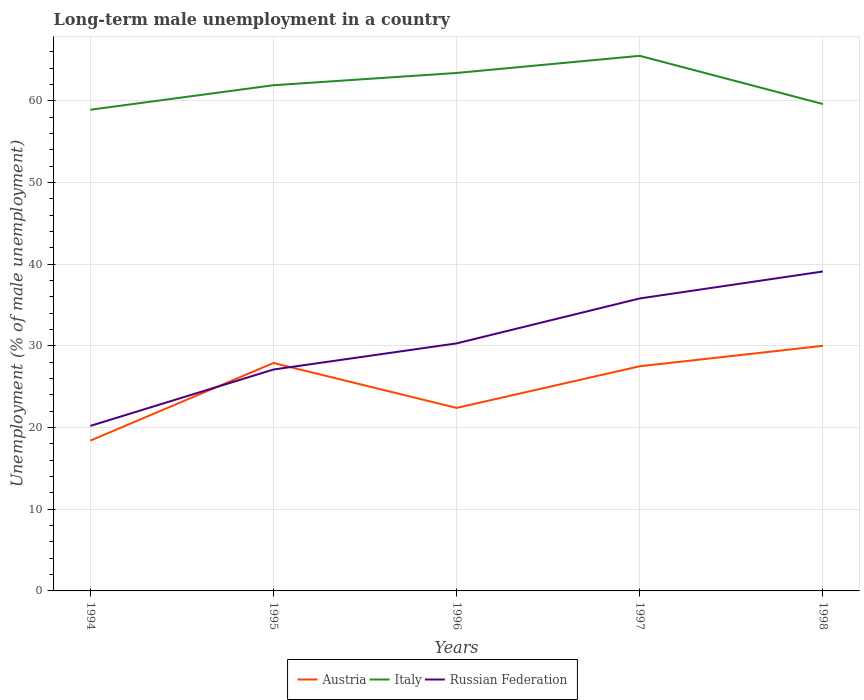How many different coloured lines are there?
Keep it short and to the point. 3. Does the line corresponding to Italy intersect with the line corresponding to Russian Federation?
Give a very brief answer. No. Is the number of lines equal to the number of legend labels?
Offer a very short reply. Yes. Across all years, what is the maximum percentage of long-term unemployed male population in Russian Federation?
Make the answer very short. 20.2. In which year was the percentage of long-term unemployed male population in Austria maximum?
Ensure brevity in your answer.  1994. What is the total percentage of long-term unemployed male population in Italy in the graph?
Give a very brief answer. -3.6. What is the difference between the highest and the second highest percentage of long-term unemployed male population in Russian Federation?
Ensure brevity in your answer.  18.9. What is the difference between the highest and the lowest percentage of long-term unemployed male population in Italy?
Give a very brief answer. 3. Is the percentage of long-term unemployed male population in Russian Federation strictly greater than the percentage of long-term unemployed male population in Italy over the years?
Make the answer very short. Yes. How many lines are there?
Make the answer very short. 3. Are the values on the major ticks of Y-axis written in scientific E-notation?
Give a very brief answer. No. Does the graph contain grids?
Provide a short and direct response. Yes. Where does the legend appear in the graph?
Your answer should be very brief. Bottom center. How many legend labels are there?
Provide a succinct answer. 3. How are the legend labels stacked?
Your answer should be compact. Horizontal. What is the title of the graph?
Your response must be concise. Long-term male unemployment in a country. What is the label or title of the Y-axis?
Offer a terse response. Unemployment (% of male unemployment). What is the Unemployment (% of male unemployment) of Austria in 1994?
Offer a terse response. 18.4. What is the Unemployment (% of male unemployment) in Italy in 1994?
Give a very brief answer. 58.9. What is the Unemployment (% of male unemployment) in Russian Federation in 1994?
Ensure brevity in your answer.  20.2. What is the Unemployment (% of male unemployment) of Austria in 1995?
Provide a short and direct response. 27.9. What is the Unemployment (% of male unemployment) of Italy in 1995?
Give a very brief answer. 61.9. What is the Unemployment (% of male unemployment) of Russian Federation in 1995?
Give a very brief answer. 27.1. What is the Unemployment (% of male unemployment) in Austria in 1996?
Your answer should be very brief. 22.4. What is the Unemployment (% of male unemployment) of Italy in 1996?
Offer a terse response. 63.4. What is the Unemployment (% of male unemployment) of Russian Federation in 1996?
Provide a short and direct response. 30.3. What is the Unemployment (% of male unemployment) of Italy in 1997?
Provide a short and direct response. 65.5. What is the Unemployment (% of male unemployment) in Russian Federation in 1997?
Provide a succinct answer. 35.8. What is the Unemployment (% of male unemployment) of Italy in 1998?
Your response must be concise. 59.6. What is the Unemployment (% of male unemployment) in Russian Federation in 1998?
Your response must be concise. 39.1. Across all years, what is the maximum Unemployment (% of male unemployment) of Austria?
Provide a succinct answer. 30. Across all years, what is the maximum Unemployment (% of male unemployment) of Italy?
Make the answer very short. 65.5. Across all years, what is the maximum Unemployment (% of male unemployment) in Russian Federation?
Offer a terse response. 39.1. Across all years, what is the minimum Unemployment (% of male unemployment) in Austria?
Ensure brevity in your answer.  18.4. Across all years, what is the minimum Unemployment (% of male unemployment) of Italy?
Your answer should be very brief. 58.9. Across all years, what is the minimum Unemployment (% of male unemployment) of Russian Federation?
Ensure brevity in your answer.  20.2. What is the total Unemployment (% of male unemployment) of Austria in the graph?
Your response must be concise. 126.2. What is the total Unemployment (% of male unemployment) of Italy in the graph?
Make the answer very short. 309.3. What is the total Unemployment (% of male unemployment) in Russian Federation in the graph?
Give a very brief answer. 152.5. What is the difference between the Unemployment (% of male unemployment) of Austria in 1994 and that in 1995?
Your response must be concise. -9.5. What is the difference between the Unemployment (% of male unemployment) in Russian Federation in 1994 and that in 1995?
Your response must be concise. -6.9. What is the difference between the Unemployment (% of male unemployment) of Italy in 1994 and that in 1996?
Offer a very short reply. -4.5. What is the difference between the Unemployment (% of male unemployment) of Russian Federation in 1994 and that in 1996?
Your answer should be very brief. -10.1. What is the difference between the Unemployment (% of male unemployment) of Russian Federation in 1994 and that in 1997?
Provide a succinct answer. -15.6. What is the difference between the Unemployment (% of male unemployment) of Austria in 1994 and that in 1998?
Your answer should be very brief. -11.6. What is the difference between the Unemployment (% of male unemployment) in Russian Federation in 1994 and that in 1998?
Give a very brief answer. -18.9. What is the difference between the Unemployment (% of male unemployment) of Austria in 1995 and that in 1996?
Offer a terse response. 5.5. What is the difference between the Unemployment (% of male unemployment) in Russian Federation in 1995 and that in 1996?
Make the answer very short. -3.2. What is the difference between the Unemployment (% of male unemployment) in Austria in 1995 and that in 1997?
Your response must be concise. 0.4. What is the difference between the Unemployment (% of male unemployment) in Russian Federation in 1995 and that in 1998?
Give a very brief answer. -12. What is the difference between the Unemployment (% of male unemployment) in Italy in 1996 and that in 1997?
Your answer should be very brief. -2.1. What is the difference between the Unemployment (% of male unemployment) of Austria in 1996 and that in 1998?
Offer a very short reply. -7.6. What is the difference between the Unemployment (% of male unemployment) of Italy in 1996 and that in 1998?
Give a very brief answer. 3.8. What is the difference between the Unemployment (% of male unemployment) in Austria in 1997 and that in 1998?
Provide a succinct answer. -2.5. What is the difference between the Unemployment (% of male unemployment) of Italy in 1997 and that in 1998?
Keep it short and to the point. 5.9. What is the difference between the Unemployment (% of male unemployment) in Russian Federation in 1997 and that in 1998?
Your response must be concise. -3.3. What is the difference between the Unemployment (% of male unemployment) of Austria in 1994 and the Unemployment (% of male unemployment) of Italy in 1995?
Give a very brief answer. -43.5. What is the difference between the Unemployment (% of male unemployment) of Italy in 1994 and the Unemployment (% of male unemployment) of Russian Federation in 1995?
Provide a short and direct response. 31.8. What is the difference between the Unemployment (% of male unemployment) in Austria in 1994 and the Unemployment (% of male unemployment) in Italy in 1996?
Make the answer very short. -45. What is the difference between the Unemployment (% of male unemployment) of Italy in 1994 and the Unemployment (% of male unemployment) of Russian Federation in 1996?
Offer a terse response. 28.6. What is the difference between the Unemployment (% of male unemployment) of Austria in 1994 and the Unemployment (% of male unemployment) of Italy in 1997?
Offer a very short reply. -47.1. What is the difference between the Unemployment (% of male unemployment) of Austria in 1994 and the Unemployment (% of male unemployment) of Russian Federation in 1997?
Your response must be concise. -17.4. What is the difference between the Unemployment (% of male unemployment) of Italy in 1994 and the Unemployment (% of male unemployment) of Russian Federation in 1997?
Give a very brief answer. 23.1. What is the difference between the Unemployment (% of male unemployment) of Austria in 1994 and the Unemployment (% of male unemployment) of Italy in 1998?
Make the answer very short. -41.2. What is the difference between the Unemployment (% of male unemployment) in Austria in 1994 and the Unemployment (% of male unemployment) in Russian Federation in 1998?
Keep it short and to the point. -20.7. What is the difference between the Unemployment (% of male unemployment) in Italy in 1994 and the Unemployment (% of male unemployment) in Russian Federation in 1998?
Ensure brevity in your answer.  19.8. What is the difference between the Unemployment (% of male unemployment) of Austria in 1995 and the Unemployment (% of male unemployment) of Italy in 1996?
Give a very brief answer. -35.5. What is the difference between the Unemployment (% of male unemployment) of Italy in 1995 and the Unemployment (% of male unemployment) of Russian Federation in 1996?
Offer a very short reply. 31.6. What is the difference between the Unemployment (% of male unemployment) of Austria in 1995 and the Unemployment (% of male unemployment) of Italy in 1997?
Keep it short and to the point. -37.6. What is the difference between the Unemployment (% of male unemployment) in Austria in 1995 and the Unemployment (% of male unemployment) in Russian Federation in 1997?
Offer a terse response. -7.9. What is the difference between the Unemployment (% of male unemployment) in Italy in 1995 and the Unemployment (% of male unemployment) in Russian Federation in 1997?
Make the answer very short. 26.1. What is the difference between the Unemployment (% of male unemployment) in Austria in 1995 and the Unemployment (% of male unemployment) in Italy in 1998?
Offer a terse response. -31.7. What is the difference between the Unemployment (% of male unemployment) in Italy in 1995 and the Unemployment (% of male unemployment) in Russian Federation in 1998?
Provide a short and direct response. 22.8. What is the difference between the Unemployment (% of male unemployment) in Austria in 1996 and the Unemployment (% of male unemployment) in Italy in 1997?
Offer a terse response. -43.1. What is the difference between the Unemployment (% of male unemployment) in Austria in 1996 and the Unemployment (% of male unemployment) in Russian Federation in 1997?
Your response must be concise. -13.4. What is the difference between the Unemployment (% of male unemployment) in Italy in 1996 and the Unemployment (% of male unemployment) in Russian Federation in 1997?
Make the answer very short. 27.6. What is the difference between the Unemployment (% of male unemployment) of Austria in 1996 and the Unemployment (% of male unemployment) of Italy in 1998?
Offer a very short reply. -37.2. What is the difference between the Unemployment (% of male unemployment) in Austria in 1996 and the Unemployment (% of male unemployment) in Russian Federation in 1998?
Your answer should be compact. -16.7. What is the difference between the Unemployment (% of male unemployment) in Italy in 1996 and the Unemployment (% of male unemployment) in Russian Federation in 1998?
Make the answer very short. 24.3. What is the difference between the Unemployment (% of male unemployment) of Austria in 1997 and the Unemployment (% of male unemployment) of Italy in 1998?
Provide a succinct answer. -32.1. What is the difference between the Unemployment (% of male unemployment) of Austria in 1997 and the Unemployment (% of male unemployment) of Russian Federation in 1998?
Offer a very short reply. -11.6. What is the difference between the Unemployment (% of male unemployment) of Italy in 1997 and the Unemployment (% of male unemployment) of Russian Federation in 1998?
Make the answer very short. 26.4. What is the average Unemployment (% of male unemployment) in Austria per year?
Your answer should be compact. 25.24. What is the average Unemployment (% of male unemployment) of Italy per year?
Offer a terse response. 61.86. What is the average Unemployment (% of male unemployment) in Russian Federation per year?
Ensure brevity in your answer.  30.5. In the year 1994, what is the difference between the Unemployment (% of male unemployment) in Austria and Unemployment (% of male unemployment) in Italy?
Offer a terse response. -40.5. In the year 1994, what is the difference between the Unemployment (% of male unemployment) of Italy and Unemployment (% of male unemployment) of Russian Federation?
Provide a short and direct response. 38.7. In the year 1995, what is the difference between the Unemployment (% of male unemployment) of Austria and Unemployment (% of male unemployment) of Italy?
Provide a short and direct response. -34. In the year 1995, what is the difference between the Unemployment (% of male unemployment) in Italy and Unemployment (% of male unemployment) in Russian Federation?
Provide a short and direct response. 34.8. In the year 1996, what is the difference between the Unemployment (% of male unemployment) in Austria and Unemployment (% of male unemployment) in Italy?
Your answer should be very brief. -41. In the year 1996, what is the difference between the Unemployment (% of male unemployment) in Italy and Unemployment (% of male unemployment) in Russian Federation?
Ensure brevity in your answer.  33.1. In the year 1997, what is the difference between the Unemployment (% of male unemployment) of Austria and Unemployment (% of male unemployment) of Italy?
Your answer should be compact. -38. In the year 1997, what is the difference between the Unemployment (% of male unemployment) in Austria and Unemployment (% of male unemployment) in Russian Federation?
Keep it short and to the point. -8.3. In the year 1997, what is the difference between the Unemployment (% of male unemployment) of Italy and Unemployment (% of male unemployment) of Russian Federation?
Provide a short and direct response. 29.7. In the year 1998, what is the difference between the Unemployment (% of male unemployment) of Austria and Unemployment (% of male unemployment) of Italy?
Offer a very short reply. -29.6. In the year 1998, what is the difference between the Unemployment (% of male unemployment) of Austria and Unemployment (% of male unemployment) of Russian Federation?
Provide a succinct answer. -9.1. In the year 1998, what is the difference between the Unemployment (% of male unemployment) in Italy and Unemployment (% of male unemployment) in Russian Federation?
Your answer should be very brief. 20.5. What is the ratio of the Unemployment (% of male unemployment) of Austria in 1994 to that in 1995?
Provide a succinct answer. 0.66. What is the ratio of the Unemployment (% of male unemployment) in Italy in 1994 to that in 1995?
Make the answer very short. 0.95. What is the ratio of the Unemployment (% of male unemployment) of Russian Federation in 1994 to that in 1995?
Give a very brief answer. 0.75. What is the ratio of the Unemployment (% of male unemployment) in Austria in 1994 to that in 1996?
Offer a very short reply. 0.82. What is the ratio of the Unemployment (% of male unemployment) of Italy in 1994 to that in 1996?
Give a very brief answer. 0.93. What is the ratio of the Unemployment (% of male unemployment) in Russian Federation in 1994 to that in 1996?
Offer a very short reply. 0.67. What is the ratio of the Unemployment (% of male unemployment) of Austria in 1994 to that in 1997?
Keep it short and to the point. 0.67. What is the ratio of the Unemployment (% of male unemployment) of Italy in 1994 to that in 1997?
Offer a very short reply. 0.9. What is the ratio of the Unemployment (% of male unemployment) of Russian Federation in 1994 to that in 1997?
Ensure brevity in your answer.  0.56. What is the ratio of the Unemployment (% of male unemployment) in Austria in 1994 to that in 1998?
Ensure brevity in your answer.  0.61. What is the ratio of the Unemployment (% of male unemployment) in Italy in 1994 to that in 1998?
Offer a terse response. 0.99. What is the ratio of the Unemployment (% of male unemployment) of Russian Federation in 1994 to that in 1998?
Provide a short and direct response. 0.52. What is the ratio of the Unemployment (% of male unemployment) of Austria in 1995 to that in 1996?
Your answer should be very brief. 1.25. What is the ratio of the Unemployment (% of male unemployment) in Italy in 1995 to that in 1996?
Offer a very short reply. 0.98. What is the ratio of the Unemployment (% of male unemployment) of Russian Federation in 1995 to that in 1996?
Offer a very short reply. 0.89. What is the ratio of the Unemployment (% of male unemployment) in Austria in 1995 to that in 1997?
Keep it short and to the point. 1.01. What is the ratio of the Unemployment (% of male unemployment) in Italy in 1995 to that in 1997?
Offer a very short reply. 0.94. What is the ratio of the Unemployment (% of male unemployment) in Russian Federation in 1995 to that in 1997?
Give a very brief answer. 0.76. What is the ratio of the Unemployment (% of male unemployment) in Austria in 1995 to that in 1998?
Make the answer very short. 0.93. What is the ratio of the Unemployment (% of male unemployment) in Italy in 1995 to that in 1998?
Make the answer very short. 1.04. What is the ratio of the Unemployment (% of male unemployment) in Russian Federation in 1995 to that in 1998?
Your answer should be compact. 0.69. What is the ratio of the Unemployment (% of male unemployment) of Austria in 1996 to that in 1997?
Give a very brief answer. 0.81. What is the ratio of the Unemployment (% of male unemployment) of Italy in 1996 to that in 1997?
Offer a terse response. 0.97. What is the ratio of the Unemployment (% of male unemployment) of Russian Federation in 1996 to that in 1997?
Offer a terse response. 0.85. What is the ratio of the Unemployment (% of male unemployment) in Austria in 1996 to that in 1998?
Offer a very short reply. 0.75. What is the ratio of the Unemployment (% of male unemployment) of Italy in 1996 to that in 1998?
Provide a succinct answer. 1.06. What is the ratio of the Unemployment (% of male unemployment) of Russian Federation in 1996 to that in 1998?
Provide a short and direct response. 0.77. What is the ratio of the Unemployment (% of male unemployment) in Austria in 1997 to that in 1998?
Your answer should be very brief. 0.92. What is the ratio of the Unemployment (% of male unemployment) of Italy in 1997 to that in 1998?
Provide a succinct answer. 1.1. What is the ratio of the Unemployment (% of male unemployment) in Russian Federation in 1997 to that in 1998?
Your response must be concise. 0.92. What is the difference between the highest and the second highest Unemployment (% of male unemployment) in Italy?
Your response must be concise. 2.1. 